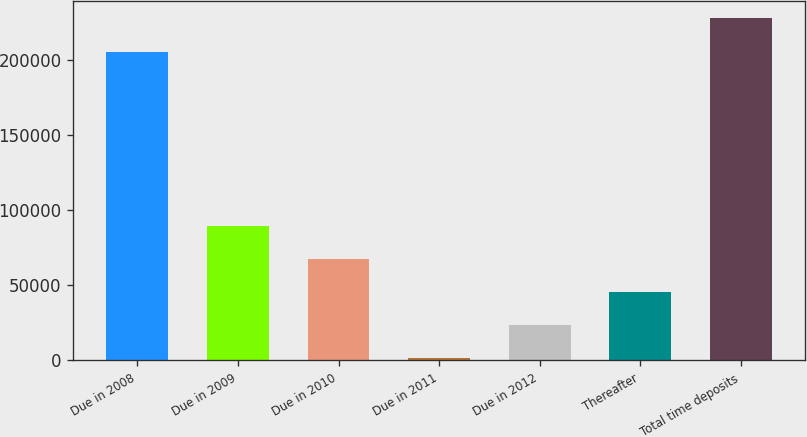Convert chart. <chart><loc_0><loc_0><loc_500><loc_500><bar_chart><fcel>Due in 2008<fcel>Due in 2009<fcel>Due in 2010<fcel>Due in 2011<fcel>Due in 2012<fcel>Thereafter<fcel>Total time deposits<nl><fcel>205359<fcel>89664.2<fcel>67640.4<fcel>1569<fcel>23592.8<fcel>45616.6<fcel>227383<nl></chart> 